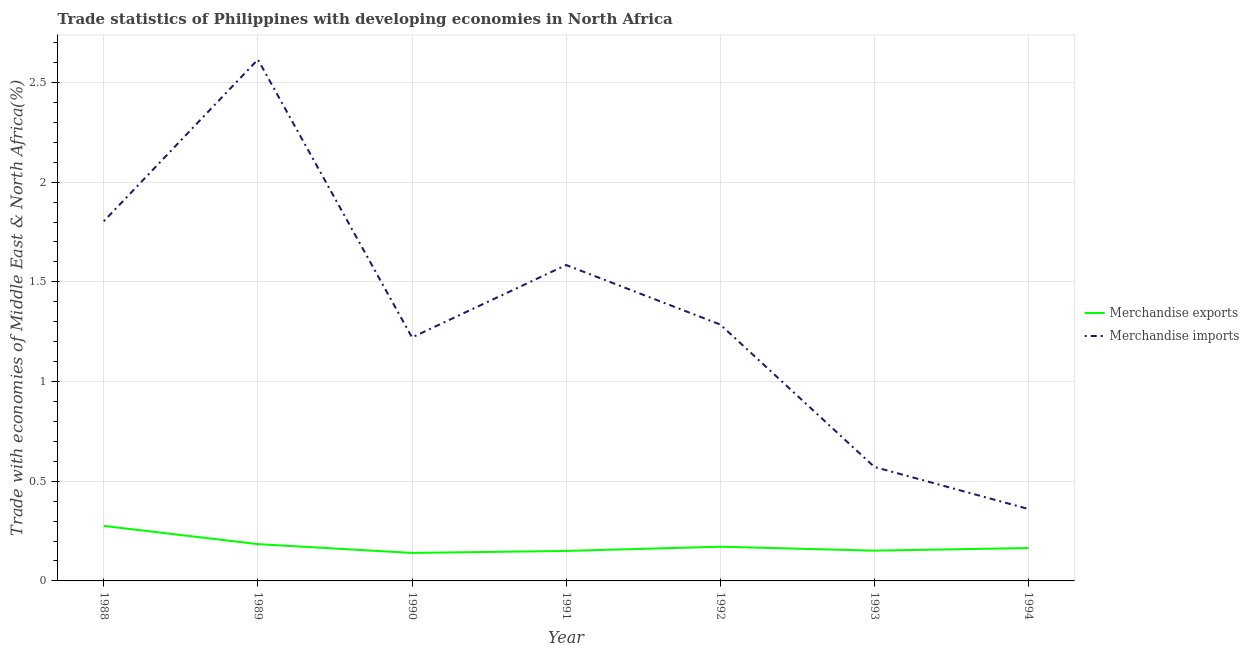Does the line corresponding to merchandise exports intersect with the line corresponding to merchandise imports?
Provide a short and direct response. No. Is the number of lines equal to the number of legend labels?
Ensure brevity in your answer.  Yes. What is the merchandise imports in 1993?
Your answer should be compact. 0.57. Across all years, what is the maximum merchandise imports?
Make the answer very short. 2.61. Across all years, what is the minimum merchandise imports?
Your response must be concise. 0.36. In which year was the merchandise exports maximum?
Keep it short and to the point. 1988. What is the total merchandise exports in the graph?
Offer a very short reply. 1.24. What is the difference between the merchandise exports in 1991 and that in 1993?
Ensure brevity in your answer.  -0. What is the difference between the merchandise imports in 1991 and the merchandise exports in 1989?
Give a very brief answer. 1.4. What is the average merchandise exports per year?
Make the answer very short. 0.18. In the year 1990, what is the difference between the merchandise imports and merchandise exports?
Your answer should be compact. 1.08. In how many years, is the merchandise imports greater than 0.8 %?
Make the answer very short. 5. What is the ratio of the merchandise exports in 1988 to that in 1992?
Your answer should be very brief. 1.61. Is the merchandise imports in 1989 less than that in 1990?
Make the answer very short. No. What is the difference between the highest and the second highest merchandise imports?
Keep it short and to the point. 0.81. What is the difference between the highest and the lowest merchandise exports?
Ensure brevity in your answer.  0.14. Is the sum of the merchandise imports in 1988 and 1991 greater than the maximum merchandise exports across all years?
Ensure brevity in your answer.  Yes. Is the merchandise imports strictly greater than the merchandise exports over the years?
Ensure brevity in your answer.  Yes. Is the merchandise imports strictly less than the merchandise exports over the years?
Offer a very short reply. No. How many lines are there?
Your response must be concise. 2. How many years are there in the graph?
Your answer should be very brief. 7. What is the difference between two consecutive major ticks on the Y-axis?
Offer a terse response. 0.5. Where does the legend appear in the graph?
Your response must be concise. Center right. How many legend labels are there?
Make the answer very short. 2. What is the title of the graph?
Make the answer very short. Trade statistics of Philippines with developing economies in North Africa. What is the label or title of the X-axis?
Keep it short and to the point. Year. What is the label or title of the Y-axis?
Give a very brief answer. Trade with economies of Middle East & North Africa(%). What is the Trade with economies of Middle East & North Africa(%) of Merchandise exports in 1988?
Your response must be concise. 0.28. What is the Trade with economies of Middle East & North Africa(%) of Merchandise imports in 1988?
Provide a succinct answer. 1.8. What is the Trade with economies of Middle East & North Africa(%) in Merchandise exports in 1989?
Your answer should be compact. 0.18. What is the Trade with economies of Middle East & North Africa(%) of Merchandise imports in 1989?
Keep it short and to the point. 2.61. What is the Trade with economies of Middle East & North Africa(%) of Merchandise exports in 1990?
Offer a very short reply. 0.14. What is the Trade with economies of Middle East & North Africa(%) in Merchandise imports in 1990?
Offer a terse response. 1.22. What is the Trade with economies of Middle East & North Africa(%) in Merchandise exports in 1991?
Provide a succinct answer. 0.15. What is the Trade with economies of Middle East & North Africa(%) of Merchandise imports in 1991?
Keep it short and to the point. 1.58. What is the Trade with economies of Middle East & North Africa(%) in Merchandise exports in 1992?
Offer a very short reply. 0.17. What is the Trade with economies of Middle East & North Africa(%) of Merchandise imports in 1992?
Offer a terse response. 1.29. What is the Trade with economies of Middle East & North Africa(%) of Merchandise exports in 1993?
Offer a very short reply. 0.15. What is the Trade with economies of Middle East & North Africa(%) of Merchandise imports in 1993?
Offer a very short reply. 0.57. What is the Trade with economies of Middle East & North Africa(%) of Merchandise exports in 1994?
Keep it short and to the point. 0.16. What is the Trade with economies of Middle East & North Africa(%) of Merchandise imports in 1994?
Your answer should be very brief. 0.36. Across all years, what is the maximum Trade with economies of Middle East & North Africa(%) of Merchandise exports?
Your answer should be very brief. 0.28. Across all years, what is the maximum Trade with economies of Middle East & North Africa(%) in Merchandise imports?
Offer a terse response. 2.61. Across all years, what is the minimum Trade with economies of Middle East & North Africa(%) of Merchandise exports?
Give a very brief answer. 0.14. Across all years, what is the minimum Trade with economies of Middle East & North Africa(%) of Merchandise imports?
Keep it short and to the point. 0.36. What is the total Trade with economies of Middle East & North Africa(%) of Merchandise exports in the graph?
Provide a short and direct response. 1.24. What is the total Trade with economies of Middle East & North Africa(%) in Merchandise imports in the graph?
Your response must be concise. 9.44. What is the difference between the Trade with economies of Middle East & North Africa(%) in Merchandise exports in 1988 and that in 1989?
Offer a very short reply. 0.09. What is the difference between the Trade with economies of Middle East & North Africa(%) in Merchandise imports in 1988 and that in 1989?
Give a very brief answer. -0.81. What is the difference between the Trade with economies of Middle East & North Africa(%) in Merchandise exports in 1988 and that in 1990?
Keep it short and to the point. 0.14. What is the difference between the Trade with economies of Middle East & North Africa(%) in Merchandise imports in 1988 and that in 1990?
Make the answer very short. 0.58. What is the difference between the Trade with economies of Middle East & North Africa(%) of Merchandise exports in 1988 and that in 1991?
Your answer should be very brief. 0.13. What is the difference between the Trade with economies of Middle East & North Africa(%) in Merchandise imports in 1988 and that in 1991?
Your answer should be compact. 0.22. What is the difference between the Trade with economies of Middle East & North Africa(%) in Merchandise exports in 1988 and that in 1992?
Ensure brevity in your answer.  0.1. What is the difference between the Trade with economies of Middle East & North Africa(%) of Merchandise imports in 1988 and that in 1992?
Provide a succinct answer. 0.52. What is the difference between the Trade with economies of Middle East & North Africa(%) in Merchandise exports in 1988 and that in 1993?
Make the answer very short. 0.12. What is the difference between the Trade with economies of Middle East & North Africa(%) of Merchandise imports in 1988 and that in 1993?
Offer a terse response. 1.23. What is the difference between the Trade with economies of Middle East & North Africa(%) in Merchandise exports in 1988 and that in 1994?
Keep it short and to the point. 0.11. What is the difference between the Trade with economies of Middle East & North Africa(%) in Merchandise imports in 1988 and that in 1994?
Give a very brief answer. 1.44. What is the difference between the Trade with economies of Middle East & North Africa(%) in Merchandise exports in 1989 and that in 1990?
Your answer should be compact. 0.04. What is the difference between the Trade with economies of Middle East & North Africa(%) of Merchandise imports in 1989 and that in 1990?
Provide a short and direct response. 1.39. What is the difference between the Trade with economies of Middle East & North Africa(%) of Merchandise exports in 1989 and that in 1991?
Keep it short and to the point. 0.03. What is the difference between the Trade with economies of Middle East & North Africa(%) of Merchandise imports in 1989 and that in 1991?
Keep it short and to the point. 1.03. What is the difference between the Trade with economies of Middle East & North Africa(%) of Merchandise exports in 1989 and that in 1992?
Offer a very short reply. 0.01. What is the difference between the Trade with economies of Middle East & North Africa(%) of Merchandise imports in 1989 and that in 1992?
Provide a succinct answer. 1.33. What is the difference between the Trade with economies of Middle East & North Africa(%) of Merchandise exports in 1989 and that in 1993?
Give a very brief answer. 0.03. What is the difference between the Trade with economies of Middle East & North Africa(%) in Merchandise imports in 1989 and that in 1993?
Make the answer very short. 2.04. What is the difference between the Trade with economies of Middle East & North Africa(%) in Merchandise exports in 1989 and that in 1994?
Provide a short and direct response. 0.02. What is the difference between the Trade with economies of Middle East & North Africa(%) of Merchandise imports in 1989 and that in 1994?
Offer a terse response. 2.25. What is the difference between the Trade with economies of Middle East & North Africa(%) of Merchandise exports in 1990 and that in 1991?
Offer a terse response. -0.01. What is the difference between the Trade with economies of Middle East & North Africa(%) in Merchandise imports in 1990 and that in 1991?
Offer a very short reply. -0.36. What is the difference between the Trade with economies of Middle East & North Africa(%) of Merchandise exports in 1990 and that in 1992?
Provide a short and direct response. -0.03. What is the difference between the Trade with economies of Middle East & North Africa(%) of Merchandise imports in 1990 and that in 1992?
Provide a succinct answer. -0.06. What is the difference between the Trade with economies of Middle East & North Africa(%) of Merchandise exports in 1990 and that in 1993?
Ensure brevity in your answer.  -0.01. What is the difference between the Trade with economies of Middle East & North Africa(%) of Merchandise imports in 1990 and that in 1993?
Provide a short and direct response. 0.65. What is the difference between the Trade with economies of Middle East & North Africa(%) in Merchandise exports in 1990 and that in 1994?
Ensure brevity in your answer.  -0.02. What is the difference between the Trade with economies of Middle East & North Africa(%) in Merchandise imports in 1990 and that in 1994?
Make the answer very short. 0.86. What is the difference between the Trade with economies of Middle East & North Africa(%) in Merchandise exports in 1991 and that in 1992?
Keep it short and to the point. -0.02. What is the difference between the Trade with economies of Middle East & North Africa(%) of Merchandise imports in 1991 and that in 1992?
Make the answer very short. 0.3. What is the difference between the Trade with economies of Middle East & North Africa(%) in Merchandise exports in 1991 and that in 1993?
Give a very brief answer. -0. What is the difference between the Trade with economies of Middle East & North Africa(%) of Merchandise imports in 1991 and that in 1993?
Give a very brief answer. 1.01. What is the difference between the Trade with economies of Middle East & North Africa(%) in Merchandise exports in 1991 and that in 1994?
Your answer should be very brief. -0.01. What is the difference between the Trade with economies of Middle East & North Africa(%) of Merchandise imports in 1991 and that in 1994?
Your response must be concise. 1.22. What is the difference between the Trade with economies of Middle East & North Africa(%) in Merchandise exports in 1992 and that in 1993?
Offer a terse response. 0.02. What is the difference between the Trade with economies of Middle East & North Africa(%) of Merchandise exports in 1992 and that in 1994?
Give a very brief answer. 0.01. What is the difference between the Trade with economies of Middle East & North Africa(%) in Merchandise imports in 1992 and that in 1994?
Your response must be concise. 0.93. What is the difference between the Trade with economies of Middle East & North Africa(%) in Merchandise exports in 1993 and that in 1994?
Your answer should be compact. -0.01. What is the difference between the Trade with economies of Middle East & North Africa(%) in Merchandise imports in 1993 and that in 1994?
Your response must be concise. 0.21. What is the difference between the Trade with economies of Middle East & North Africa(%) in Merchandise exports in 1988 and the Trade with economies of Middle East & North Africa(%) in Merchandise imports in 1989?
Keep it short and to the point. -2.34. What is the difference between the Trade with economies of Middle East & North Africa(%) in Merchandise exports in 1988 and the Trade with economies of Middle East & North Africa(%) in Merchandise imports in 1990?
Keep it short and to the point. -0.95. What is the difference between the Trade with economies of Middle East & North Africa(%) in Merchandise exports in 1988 and the Trade with economies of Middle East & North Africa(%) in Merchandise imports in 1991?
Give a very brief answer. -1.31. What is the difference between the Trade with economies of Middle East & North Africa(%) of Merchandise exports in 1988 and the Trade with economies of Middle East & North Africa(%) of Merchandise imports in 1992?
Your response must be concise. -1.01. What is the difference between the Trade with economies of Middle East & North Africa(%) in Merchandise exports in 1988 and the Trade with economies of Middle East & North Africa(%) in Merchandise imports in 1993?
Give a very brief answer. -0.3. What is the difference between the Trade with economies of Middle East & North Africa(%) in Merchandise exports in 1988 and the Trade with economies of Middle East & North Africa(%) in Merchandise imports in 1994?
Your response must be concise. -0.08. What is the difference between the Trade with economies of Middle East & North Africa(%) in Merchandise exports in 1989 and the Trade with economies of Middle East & North Africa(%) in Merchandise imports in 1990?
Ensure brevity in your answer.  -1.04. What is the difference between the Trade with economies of Middle East & North Africa(%) of Merchandise exports in 1989 and the Trade with economies of Middle East & North Africa(%) of Merchandise imports in 1991?
Your answer should be very brief. -1.4. What is the difference between the Trade with economies of Middle East & North Africa(%) of Merchandise exports in 1989 and the Trade with economies of Middle East & North Africa(%) of Merchandise imports in 1992?
Your answer should be compact. -1.1. What is the difference between the Trade with economies of Middle East & North Africa(%) of Merchandise exports in 1989 and the Trade with economies of Middle East & North Africa(%) of Merchandise imports in 1993?
Ensure brevity in your answer.  -0.39. What is the difference between the Trade with economies of Middle East & North Africa(%) in Merchandise exports in 1989 and the Trade with economies of Middle East & North Africa(%) in Merchandise imports in 1994?
Your answer should be compact. -0.18. What is the difference between the Trade with economies of Middle East & North Africa(%) of Merchandise exports in 1990 and the Trade with economies of Middle East & North Africa(%) of Merchandise imports in 1991?
Your answer should be very brief. -1.44. What is the difference between the Trade with economies of Middle East & North Africa(%) in Merchandise exports in 1990 and the Trade with economies of Middle East & North Africa(%) in Merchandise imports in 1992?
Your answer should be very brief. -1.15. What is the difference between the Trade with economies of Middle East & North Africa(%) in Merchandise exports in 1990 and the Trade with economies of Middle East & North Africa(%) in Merchandise imports in 1993?
Your answer should be compact. -0.43. What is the difference between the Trade with economies of Middle East & North Africa(%) in Merchandise exports in 1990 and the Trade with economies of Middle East & North Africa(%) in Merchandise imports in 1994?
Provide a succinct answer. -0.22. What is the difference between the Trade with economies of Middle East & North Africa(%) in Merchandise exports in 1991 and the Trade with economies of Middle East & North Africa(%) in Merchandise imports in 1992?
Offer a very short reply. -1.14. What is the difference between the Trade with economies of Middle East & North Africa(%) of Merchandise exports in 1991 and the Trade with economies of Middle East & North Africa(%) of Merchandise imports in 1993?
Your answer should be compact. -0.42. What is the difference between the Trade with economies of Middle East & North Africa(%) of Merchandise exports in 1991 and the Trade with economies of Middle East & North Africa(%) of Merchandise imports in 1994?
Provide a short and direct response. -0.21. What is the difference between the Trade with economies of Middle East & North Africa(%) of Merchandise exports in 1992 and the Trade with economies of Middle East & North Africa(%) of Merchandise imports in 1993?
Provide a succinct answer. -0.4. What is the difference between the Trade with economies of Middle East & North Africa(%) of Merchandise exports in 1992 and the Trade with economies of Middle East & North Africa(%) of Merchandise imports in 1994?
Provide a succinct answer. -0.19. What is the difference between the Trade with economies of Middle East & North Africa(%) of Merchandise exports in 1993 and the Trade with economies of Middle East & North Africa(%) of Merchandise imports in 1994?
Your answer should be compact. -0.21. What is the average Trade with economies of Middle East & North Africa(%) of Merchandise exports per year?
Give a very brief answer. 0.18. What is the average Trade with economies of Middle East & North Africa(%) of Merchandise imports per year?
Provide a succinct answer. 1.35. In the year 1988, what is the difference between the Trade with economies of Middle East & North Africa(%) of Merchandise exports and Trade with economies of Middle East & North Africa(%) of Merchandise imports?
Offer a terse response. -1.53. In the year 1989, what is the difference between the Trade with economies of Middle East & North Africa(%) of Merchandise exports and Trade with economies of Middle East & North Africa(%) of Merchandise imports?
Your response must be concise. -2.43. In the year 1990, what is the difference between the Trade with economies of Middle East & North Africa(%) in Merchandise exports and Trade with economies of Middle East & North Africa(%) in Merchandise imports?
Your answer should be compact. -1.08. In the year 1991, what is the difference between the Trade with economies of Middle East & North Africa(%) of Merchandise exports and Trade with economies of Middle East & North Africa(%) of Merchandise imports?
Ensure brevity in your answer.  -1.43. In the year 1992, what is the difference between the Trade with economies of Middle East & North Africa(%) of Merchandise exports and Trade with economies of Middle East & North Africa(%) of Merchandise imports?
Give a very brief answer. -1.11. In the year 1993, what is the difference between the Trade with economies of Middle East & North Africa(%) in Merchandise exports and Trade with economies of Middle East & North Africa(%) in Merchandise imports?
Offer a very short reply. -0.42. In the year 1994, what is the difference between the Trade with economies of Middle East & North Africa(%) in Merchandise exports and Trade with economies of Middle East & North Africa(%) in Merchandise imports?
Your response must be concise. -0.2. What is the ratio of the Trade with economies of Middle East & North Africa(%) in Merchandise exports in 1988 to that in 1989?
Provide a short and direct response. 1.49. What is the ratio of the Trade with economies of Middle East & North Africa(%) in Merchandise imports in 1988 to that in 1989?
Give a very brief answer. 0.69. What is the ratio of the Trade with economies of Middle East & North Africa(%) in Merchandise exports in 1988 to that in 1990?
Ensure brevity in your answer.  1.97. What is the ratio of the Trade with economies of Middle East & North Africa(%) in Merchandise imports in 1988 to that in 1990?
Your answer should be compact. 1.48. What is the ratio of the Trade with economies of Middle East & North Africa(%) in Merchandise exports in 1988 to that in 1991?
Give a very brief answer. 1.83. What is the ratio of the Trade with economies of Middle East & North Africa(%) in Merchandise imports in 1988 to that in 1991?
Offer a very short reply. 1.14. What is the ratio of the Trade with economies of Middle East & North Africa(%) of Merchandise exports in 1988 to that in 1992?
Provide a short and direct response. 1.61. What is the ratio of the Trade with economies of Middle East & North Africa(%) of Merchandise imports in 1988 to that in 1992?
Ensure brevity in your answer.  1.4. What is the ratio of the Trade with economies of Middle East & North Africa(%) of Merchandise exports in 1988 to that in 1993?
Offer a terse response. 1.82. What is the ratio of the Trade with economies of Middle East & North Africa(%) of Merchandise imports in 1988 to that in 1993?
Give a very brief answer. 3.16. What is the ratio of the Trade with economies of Middle East & North Africa(%) in Merchandise exports in 1988 to that in 1994?
Keep it short and to the point. 1.67. What is the ratio of the Trade with economies of Middle East & North Africa(%) in Merchandise imports in 1988 to that in 1994?
Provide a succinct answer. 5. What is the ratio of the Trade with economies of Middle East & North Africa(%) in Merchandise exports in 1989 to that in 1990?
Your response must be concise. 1.32. What is the ratio of the Trade with economies of Middle East & North Africa(%) of Merchandise imports in 1989 to that in 1990?
Offer a very short reply. 2.14. What is the ratio of the Trade with economies of Middle East & North Africa(%) of Merchandise exports in 1989 to that in 1991?
Your answer should be compact. 1.23. What is the ratio of the Trade with economies of Middle East & North Africa(%) in Merchandise imports in 1989 to that in 1991?
Your answer should be compact. 1.65. What is the ratio of the Trade with economies of Middle East & North Africa(%) in Merchandise exports in 1989 to that in 1992?
Your response must be concise. 1.08. What is the ratio of the Trade with economies of Middle East & North Africa(%) of Merchandise imports in 1989 to that in 1992?
Your response must be concise. 2.03. What is the ratio of the Trade with economies of Middle East & North Africa(%) of Merchandise exports in 1989 to that in 1993?
Your answer should be compact. 1.21. What is the ratio of the Trade with economies of Middle East & North Africa(%) in Merchandise imports in 1989 to that in 1993?
Offer a terse response. 4.57. What is the ratio of the Trade with economies of Middle East & North Africa(%) in Merchandise exports in 1989 to that in 1994?
Provide a short and direct response. 1.12. What is the ratio of the Trade with economies of Middle East & North Africa(%) in Merchandise imports in 1989 to that in 1994?
Provide a short and direct response. 7.25. What is the ratio of the Trade with economies of Middle East & North Africa(%) of Merchandise exports in 1990 to that in 1991?
Provide a short and direct response. 0.93. What is the ratio of the Trade with economies of Middle East & North Africa(%) of Merchandise imports in 1990 to that in 1991?
Keep it short and to the point. 0.77. What is the ratio of the Trade with economies of Middle East & North Africa(%) in Merchandise exports in 1990 to that in 1992?
Provide a succinct answer. 0.82. What is the ratio of the Trade with economies of Middle East & North Africa(%) of Merchandise imports in 1990 to that in 1992?
Offer a terse response. 0.95. What is the ratio of the Trade with economies of Middle East & North Africa(%) in Merchandise exports in 1990 to that in 1993?
Your answer should be very brief. 0.92. What is the ratio of the Trade with economies of Middle East & North Africa(%) in Merchandise imports in 1990 to that in 1993?
Give a very brief answer. 2.14. What is the ratio of the Trade with economies of Middle East & North Africa(%) in Merchandise exports in 1990 to that in 1994?
Offer a terse response. 0.85. What is the ratio of the Trade with economies of Middle East & North Africa(%) of Merchandise imports in 1990 to that in 1994?
Keep it short and to the point. 3.39. What is the ratio of the Trade with economies of Middle East & North Africa(%) in Merchandise exports in 1991 to that in 1992?
Make the answer very short. 0.88. What is the ratio of the Trade with economies of Middle East & North Africa(%) in Merchandise imports in 1991 to that in 1992?
Ensure brevity in your answer.  1.23. What is the ratio of the Trade with economies of Middle East & North Africa(%) of Merchandise exports in 1991 to that in 1993?
Make the answer very short. 0.99. What is the ratio of the Trade with economies of Middle East & North Africa(%) of Merchandise imports in 1991 to that in 1993?
Keep it short and to the point. 2.77. What is the ratio of the Trade with economies of Middle East & North Africa(%) in Merchandise exports in 1991 to that in 1994?
Give a very brief answer. 0.91. What is the ratio of the Trade with economies of Middle East & North Africa(%) of Merchandise imports in 1991 to that in 1994?
Your answer should be compact. 4.39. What is the ratio of the Trade with economies of Middle East & North Africa(%) in Merchandise exports in 1992 to that in 1993?
Provide a succinct answer. 1.13. What is the ratio of the Trade with economies of Middle East & North Africa(%) of Merchandise imports in 1992 to that in 1993?
Provide a short and direct response. 2.25. What is the ratio of the Trade with economies of Middle East & North Africa(%) in Merchandise exports in 1992 to that in 1994?
Give a very brief answer. 1.04. What is the ratio of the Trade with economies of Middle East & North Africa(%) in Merchandise imports in 1992 to that in 1994?
Give a very brief answer. 3.57. What is the ratio of the Trade with economies of Middle East & North Africa(%) in Merchandise exports in 1993 to that in 1994?
Offer a very short reply. 0.92. What is the ratio of the Trade with economies of Middle East & North Africa(%) of Merchandise imports in 1993 to that in 1994?
Provide a succinct answer. 1.58. What is the difference between the highest and the second highest Trade with economies of Middle East & North Africa(%) in Merchandise exports?
Ensure brevity in your answer.  0.09. What is the difference between the highest and the second highest Trade with economies of Middle East & North Africa(%) of Merchandise imports?
Provide a short and direct response. 0.81. What is the difference between the highest and the lowest Trade with economies of Middle East & North Africa(%) in Merchandise exports?
Offer a terse response. 0.14. What is the difference between the highest and the lowest Trade with economies of Middle East & North Africa(%) of Merchandise imports?
Give a very brief answer. 2.25. 